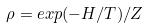Convert formula to latex. <formula><loc_0><loc_0><loc_500><loc_500>\rho = e x p ( - H / T ) / Z</formula> 